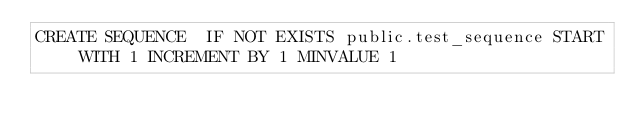Convert code to text. <code><loc_0><loc_0><loc_500><loc_500><_SQL_>CREATE SEQUENCE  IF NOT EXISTS public.test_sequence START WITH 1 INCREMENT BY 1 MINVALUE 1
</code> 